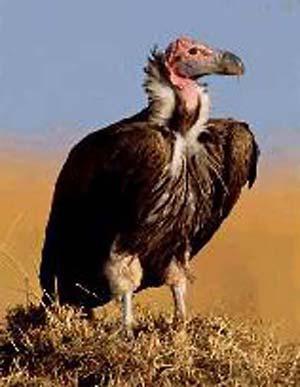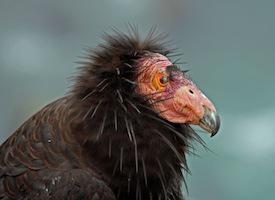The first image is the image on the left, the second image is the image on the right. Evaluate the accuracy of this statement regarding the images: "One of the images shows exactly one bald eagle with wings spread.". Is it true? Answer yes or no. No. The first image is the image on the left, the second image is the image on the right. For the images shown, is this caption "The leftmost image in the pair is of a vulture, while the rightmost is of bald eagles." true? Answer yes or no. No. 